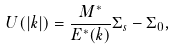<formula> <loc_0><loc_0><loc_500><loc_500>U ( | { k } | ) = \frac { M ^ { \ast } } { E ^ { \ast } ( { k } ) } \Sigma _ { s } - \Sigma _ { 0 } ,</formula> 